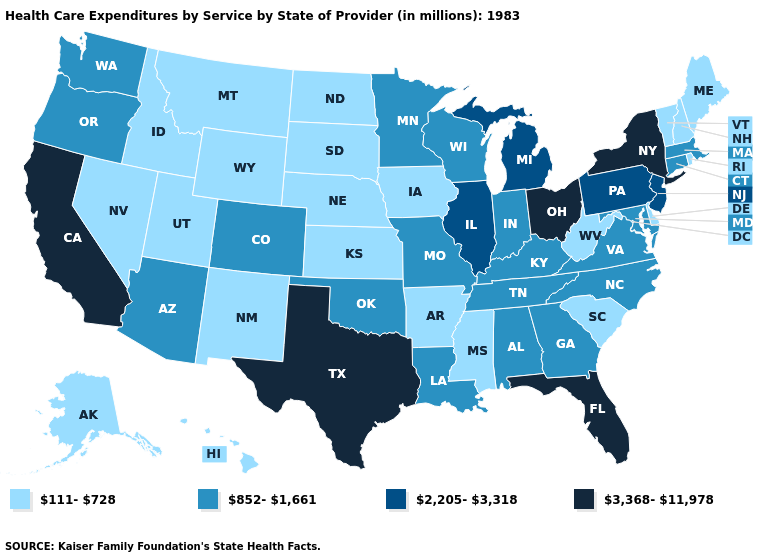What is the value of Georgia?
Concise answer only. 852-1,661. Among the states that border Nebraska , which have the highest value?
Give a very brief answer. Colorado, Missouri. What is the value of Oklahoma?
Keep it brief. 852-1,661. What is the highest value in states that border Pennsylvania?
Give a very brief answer. 3,368-11,978. What is the value of South Carolina?
Quick response, please. 111-728. What is the value of New Hampshire?
Quick response, please. 111-728. What is the lowest value in the USA?
Write a very short answer. 111-728. What is the value of New Mexico?
Concise answer only. 111-728. Name the states that have a value in the range 2,205-3,318?
Be succinct. Illinois, Michigan, New Jersey, Pennsylvania. What is the highest value in the USA?
Short answer required. 3,368-11,978. Among the states that border Arizona , does California have the highest value?
Answer briefly. Yes. What is the highest value in the South ?
Give a very brief answer. 3,368-11,978. Name the states that have a value in the range 111-728?
Write a very short answer. Alaska, Arkansas, Delaware, Hawaii, Idaho, Iowa, Kansas, Maine, Mississippi, Montana, Nebraska, Nevada, New Hampshire, New Mexico, North Dakota, Rhode Island, South Carolina, South Dakota, Utah, Vermont, West Virginia, Wyoming. Name the states that have a value in the range 852-1,661?
Short answer required. Alabama, Arizona, Colorado, Connecticut, Georgia, Indiana, Kentucky, Louisiana, Maryland, Massachusetts, Minnesota, Missouri, North Carolina, Oklahoma, Oregon, Tennessee, Virginia, Washington, Wisconsin. What is the lowest value in the USA?
Give a very brief answer. 111-728. 